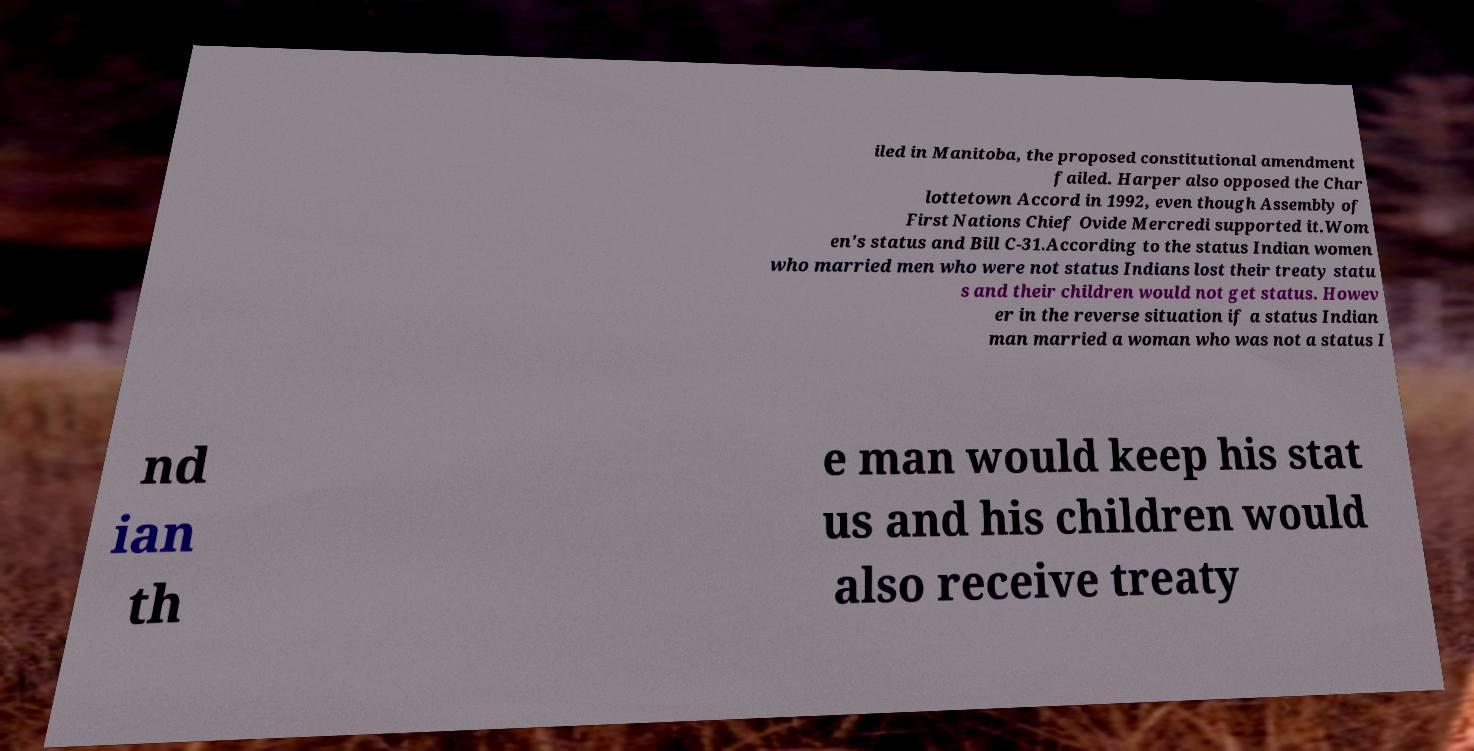Can you read and provide the text displayed in the image?This photo seems to have some interesting text. Can you extract and type it out for me? iled in Manitoba, the proposed constitutional amendment failed. Harper also opposed the Char lottetown Accord in 1992, even though Assembly of First Nations Chief Ovide Mercredi supported it.Wom en's status and Bill C-31.According to the status Indian women who married men who were not status Indians lost their treaty statu s and their children would not get status. Howev er in the reverse situation if a status Indian man married a woman who was not a status I nd ian th e man would keep his stat us and his children would also receive treaty 